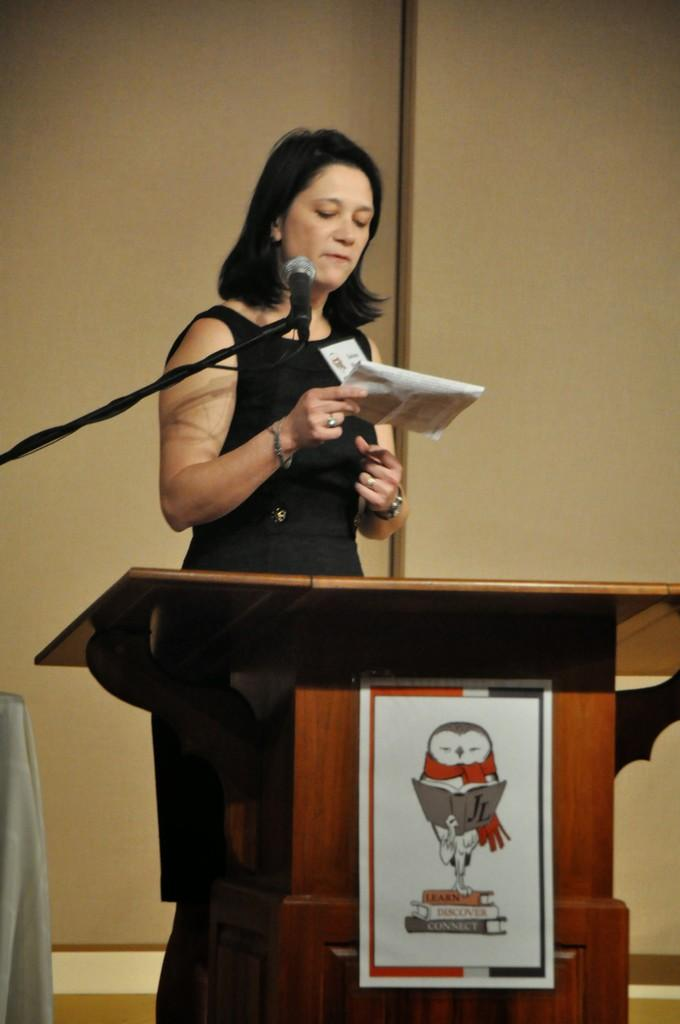What is located in the middle of the picture? There is a podium and a microphone in the middle of the picture. Who is present in the middle of the picture? There is a woman in the middle of the picture. What is the woman holding? The woman is holding papers. What can be seen in the background of the picture? There is a wall in the background of the picture. What is on the left side of the picture? There is a cloth on the left side of the picture. Can you see any worms crawling on the podium in the image? No, there are no worms present in the image. What type of station is visible in the background of the picture? There is no station visible in the image; it features a wall in the background. 